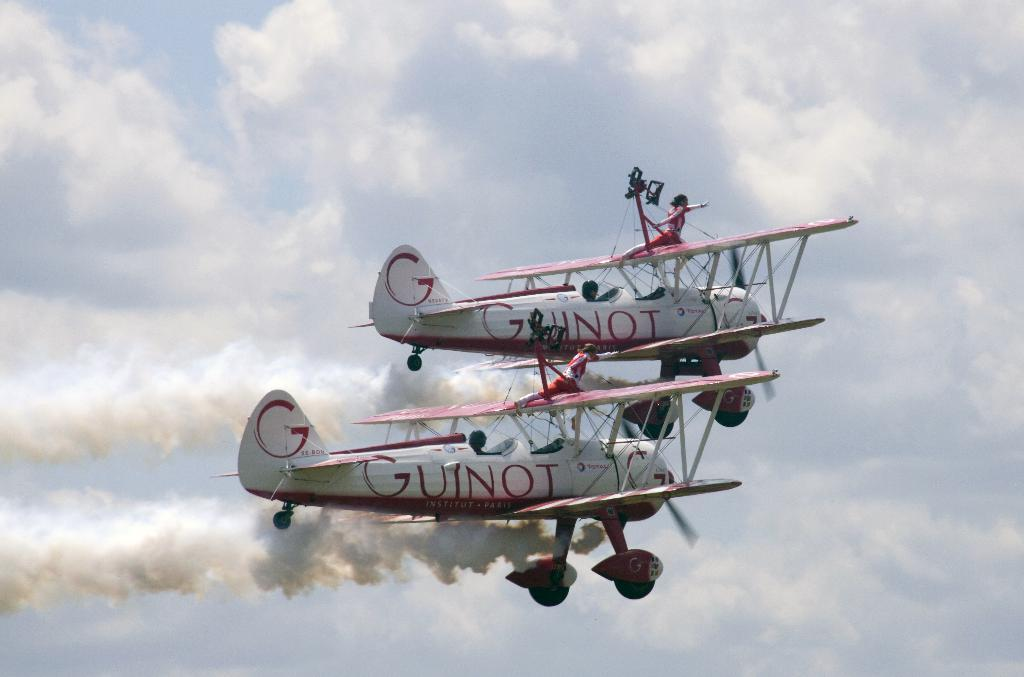<image>
Present a compact description of the photo's key features. Two airplanes flying side by side with the word Guinot written on the sides of both of them. 